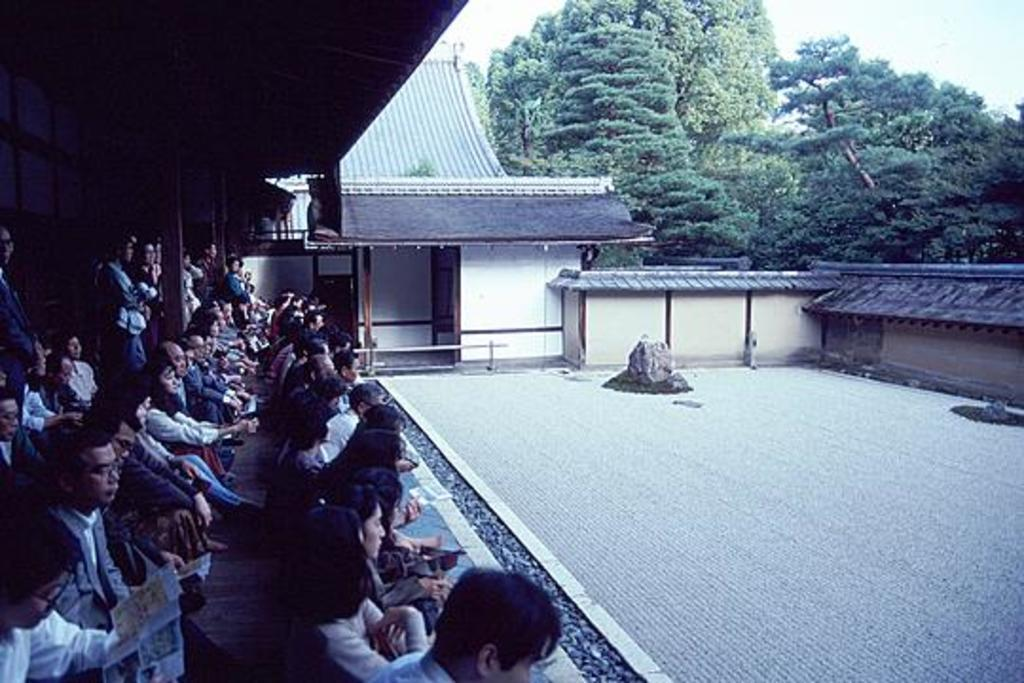How many people are in the group visible in the image? There is a group of people in the image, but the exact number cannot be determined from the provided facts. What type of structures can be seen in the image? There are wooden poles, walls, and sheds visible in the image. What can be seen in the background of the image? There are trees and the sky visible in the background of the image. How many balls are being juggled by the cattle in the image? There are no cattle or balls present in the image. 